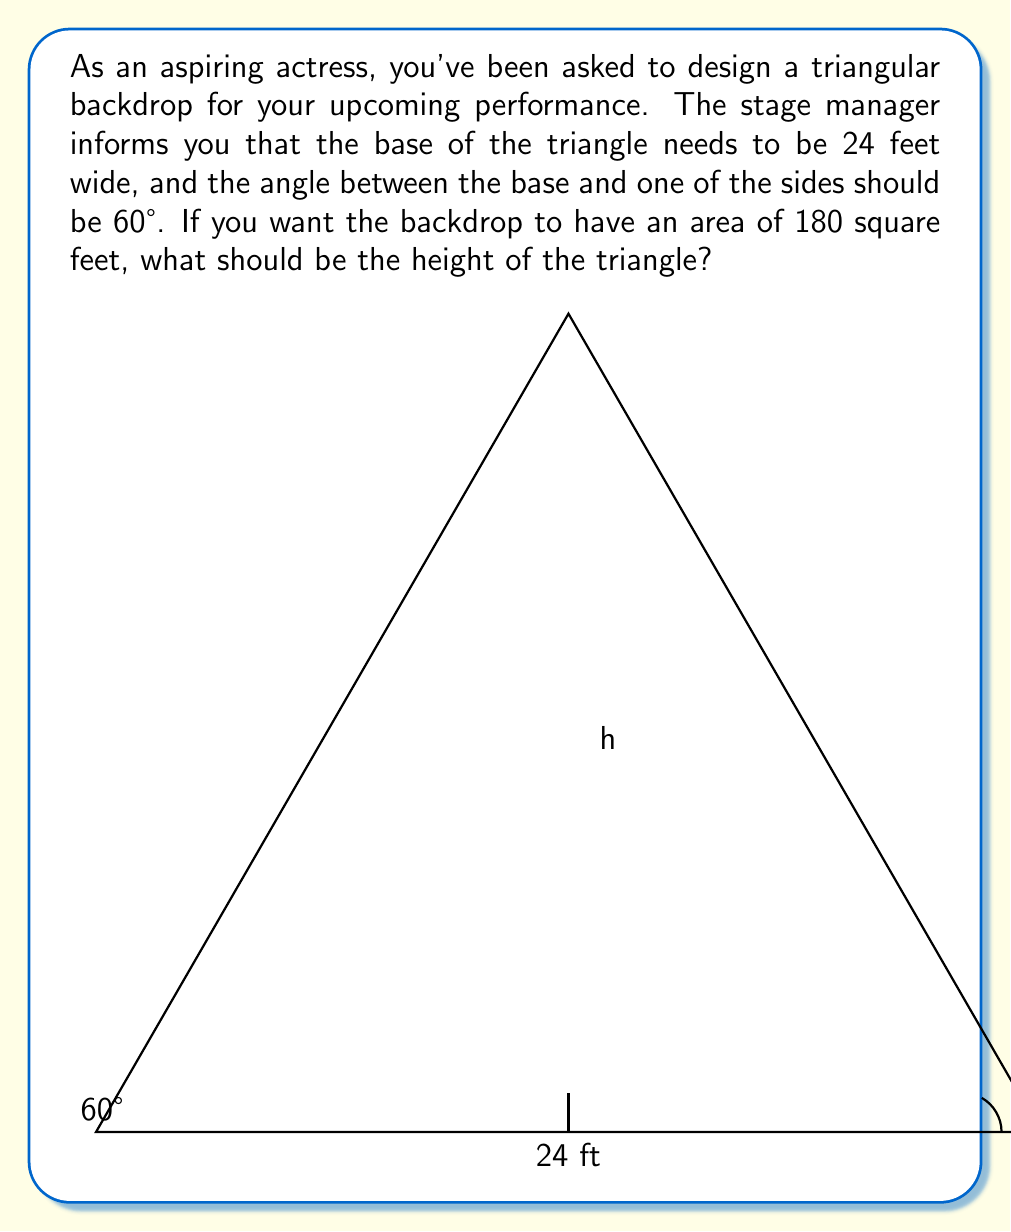Could you help me with this problem? Let's approach this step-by-step:

1) First, recall the formula for the area of a triangle:
   $$ A = \frac{1}{2} \times base \times height $$

2) We know the area (180 sq ft) and the base (24 ft), so let's substitute these:
   $$ 180 = \frac{1}{2} \times 24 \times h $$

3) Simplify:
   $$ 180 = 12h $$

4) Solve for h:
   $$ h = \frac{180}{12} = 15 $$

5) So the height of the triangle should be 15 feet.

6) Let's verify this using trigonometry. In a right triangle:
   $$ \tan 60° = \frac{height}{(base/2)} $$

7) Substitute our values:
   $$ \tan 60° = \frac{15}{12} $$

8) We know that $\tan 60° = \sqrt{3} \approx 1.732$

9) Calculate $\frac{15}{12} = 1.25$

10) The discrepancy shows that our initial calculation doesn't satisfy the 60° angle condition.

11) Let's solve it correctly using trigonometry:
    $$ \tan 60° = \frac{h}{12} $$
    $$ h = 12 \tan 60° = 12\sqrt{3} \approx 20.785 $$

12) Verify the area:
    $$ A = \frac{1}{2} \times 24 \times 20.785 = 249.42 \text{ sq ft} $$

This shows that it's impossible to have a triangle with a 24 ft base, a 60° angle, and an area of exactly 180 sq ft.
Answer: The height of the triangular backdrop should be approximately 20.785 feet (or $12\sqrt{3}$ feet) to satisfy the 60° angle condition. However, this results in an area of about 249.42 square feet, not 180 square feet as initially requested. It's not possible to satisfy all the given conditions simultaneously. 